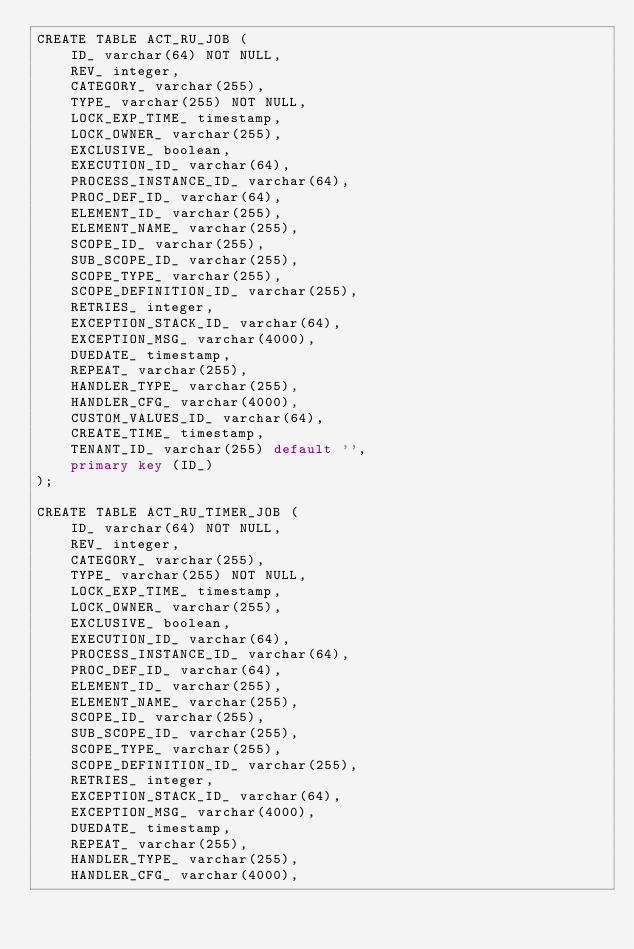Convert code to text. <code><loc_0><loc_0><loc_500><loc_500><_SQL_>CREATE TABLE ACT_RU_JOB (
    ID_ varchar(64) NOT NULL,
    REV_ integer,
    CATEGORY_ varchar(255),
    TYPE_ varchar(255) NOT NULL,
    LOCK_EXP_TIME_ timestamp,
    LOCK_OWNER_ varchar(255),
    EXCLUSIVE_ boolean,
    EXECUTION_ID_ varchar(64),
    PROCESS_INSTANCE_ID_ varchar(64),
    PROC_DEF_ID_ varchar(64),
    ELEMENT_ID_ varchar(255),
    ELEMENT_NAME_ varchar(255),
    SCOPE_ID_ varchar(255),
    SUB_SCOPE_ID_ varchar(255),
    SCOPE_TYPE_ varchar(255),
    SCOPE_DEFINITION_ID_ varchar(255),
    RETRIES_ integer,
    EXCEPTION_STACK_ID_ varchar(64),
    EXCEPTION_MSG_ varchar(4000),
    DUEDATE_ timestamp,
    REPEAT_ varchar(255),
    HANDLER_TYPE_ varchar(255),
    HANDLER_CFG_ varchar(4000),
    CUSTOM_VALUES_ID_ varchar(64),
    CREATE_TIME_ timestamp,
    TENANT_ID_ varchar(255) default '',
    primary key (ID_)
);

CREATE TABLE ACT_RU_TIMER_JOB (
    ID_ varchar(64) NOT NULL,
    REV_ integer,
    CATEGORY_ varchar(255),
    TYPE_ varchar(255) NOT NULL,
    LOCK_EXP_TIME_ timestamp,
    LOCK_OWNER_ varchar(255),
    EXCLUSIVE_ boolean,
    EXECUTION_ID_ varchar(64),
    PROCESS_INSTANCE_ID_ varchar(64),
    PROC_DEF_ID_ varchar(64),
    ELEMENT_ID_ varchar(255),
    ELEMENT_NAME_ varchar(255),
    SCOPE_ID_ varchar(255),
    SUB_SCOPE_ID_ varchar(255),
    SCOPE_TYPE_ varchar(255),
    SCOPE_DEFINITION_ID_ varchar(255),
    RETRIES_ integer,
    EXCEPTION_STACK_ID_ varchar(64),
    EXCEPTION_MSG_ varchar(4000),
    DUEDATE_ timestamp,
    REPEAT_ varchar(255),
    HANDLER_TYPE_ varchar(255),
    HANDLER_CFG_ varchar(4000),</code> 